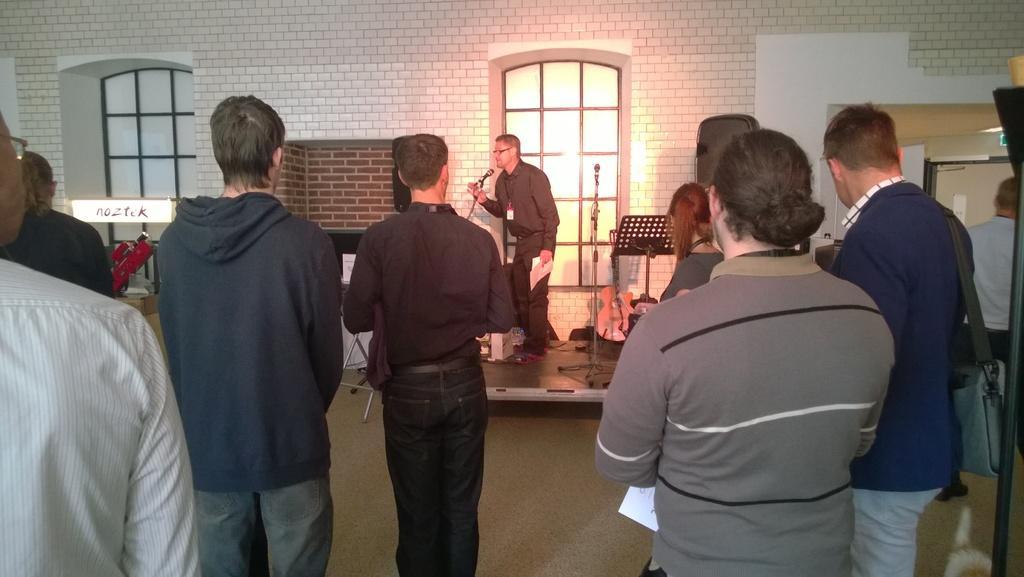Please provide a concise description of this image. In this picture we can see a few people standing. We can see a person holding a paper. There are microphones, guitar, wires and some objects. We can see some text on the white object. 